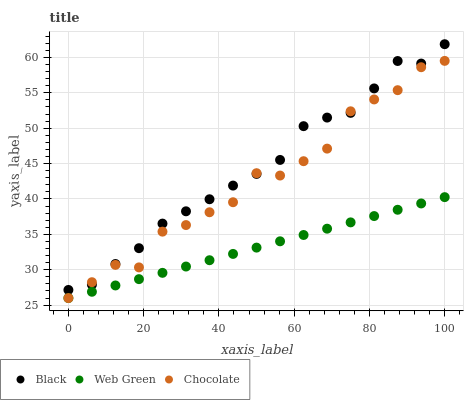Does Web Green have the minimum area under the curve?
Answer yes or no. Yes. Does Black have the maximum area under the curve?
Answer yes or no. Yes. Does Chocolate have the minimum area under the curve?
Answer yes or no. No. Does Chocolate have the maximum area under the curve?
Answer yes or no. No. Is Web Green the smoothest?
Answer yes or no. Yes. Is Chocolate the roughest?
Answer yes or no. Yes. Is Chocolate the smoothest?
Answer yes or no. No. Is Web Green the roughest?
Answer yes or no. No. Does Web Green have the lowest value?
Answer yes or no. Yes. Does Black have the highest value?
Answer yes or no. Yes. Does Chocolate have the highest value?
Answer yes or no. No. Is Web Green less than Black?
Answer yes or no. Yes. Is Black greater than Web Green?
Answer yes or no. Yes. Does Web Green intersect Chocolate?
Answer yes or no. Yes. Is Web Green less than Chocolate?
Answer yes or no. No. Is Web Green greater than Chocolate?
Answer yes or no. No. Does Web Green intersect Black?
Answer yes or no. No. 